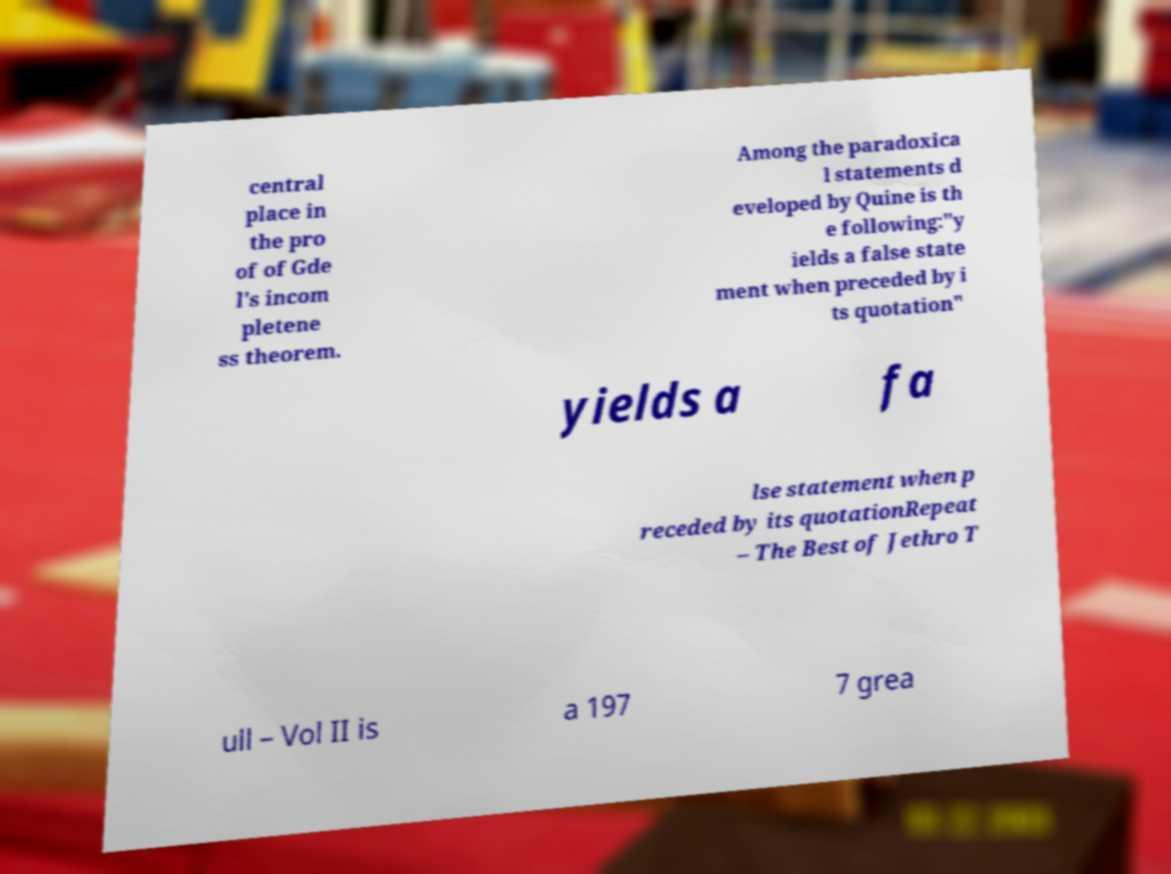Please identify and transcribe the text found in this image. central place in the pro of of Gde l's incom pletene ss theorem. Among the paradoxica l statements d eveloped by Quine is th e following:"y ields a false state ment when preceded by i ts quotation" yields a fa lse statement when p receded by its quotationRepeat – The Best of Jethro T ull – Vol II is a 197 7 grea 